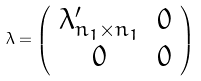<formula> <loc_0><loc_0><loc_500><loc_500>\lambda = \left ( \begin{array} { c c } \lambda ^ { \prime } _ { n _ { 1 } \times n _ { 1 } } & 0 \\ 0 & 0 \end{array} \right )</formula> 